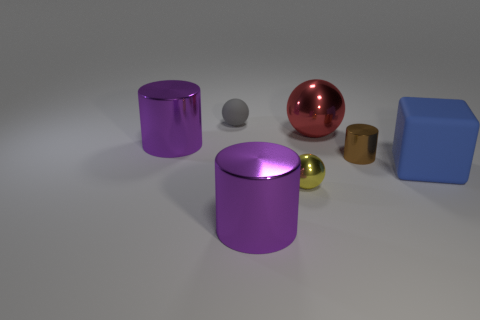How many tiny objects are yellow spheres or metal cylinders?
Offer a very short reply. 2. Does the small brown thing have the same material as the big ball?
Ensure brevity in your answer.  Yes. Is there a large rubber object of the same color as the big cube?
Offer a very short reply. No. What size is the red ball that is the same material as the small brown thing?
Keep it short and to the point. Large. There is a large object on the left side of the purple shiny thing in front of the blue rubber block that is on the right side of the tiny matte sphere; what shape is it?
Offer a terse response. Cylinder. What is the size of the other metallic object that is the same shape as the large red metal object?
Give a very brief answer. Small. There is a thing that is both on the left side of the yellow object and in front of the big blue matte block; how big is it?
Your response must be concise. Large. The tiny shiny sphere is what color?
Give a very brief answer. Yellow. There is a yellow metal sphere to the left of the small brown cylinder; what size is it?
Give a very brief answer. Small. There is a small sphere in front of the large purple shiny object behind the small brown cylinder; how many large red things are left of it?
Provide a succinct answer. 0. 